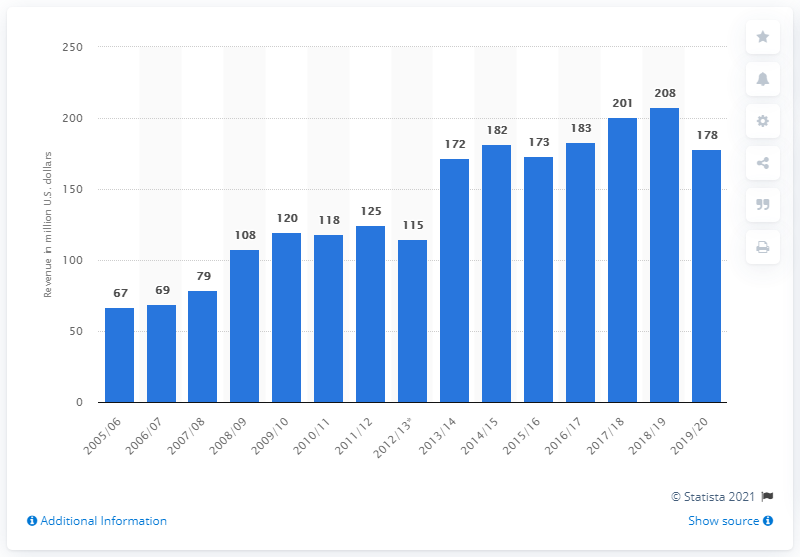Mention a couple of crucial points in this snapshot. In the 2019/2020 season, the Chicago Blackhawks earned a total revenue of $178 million. 